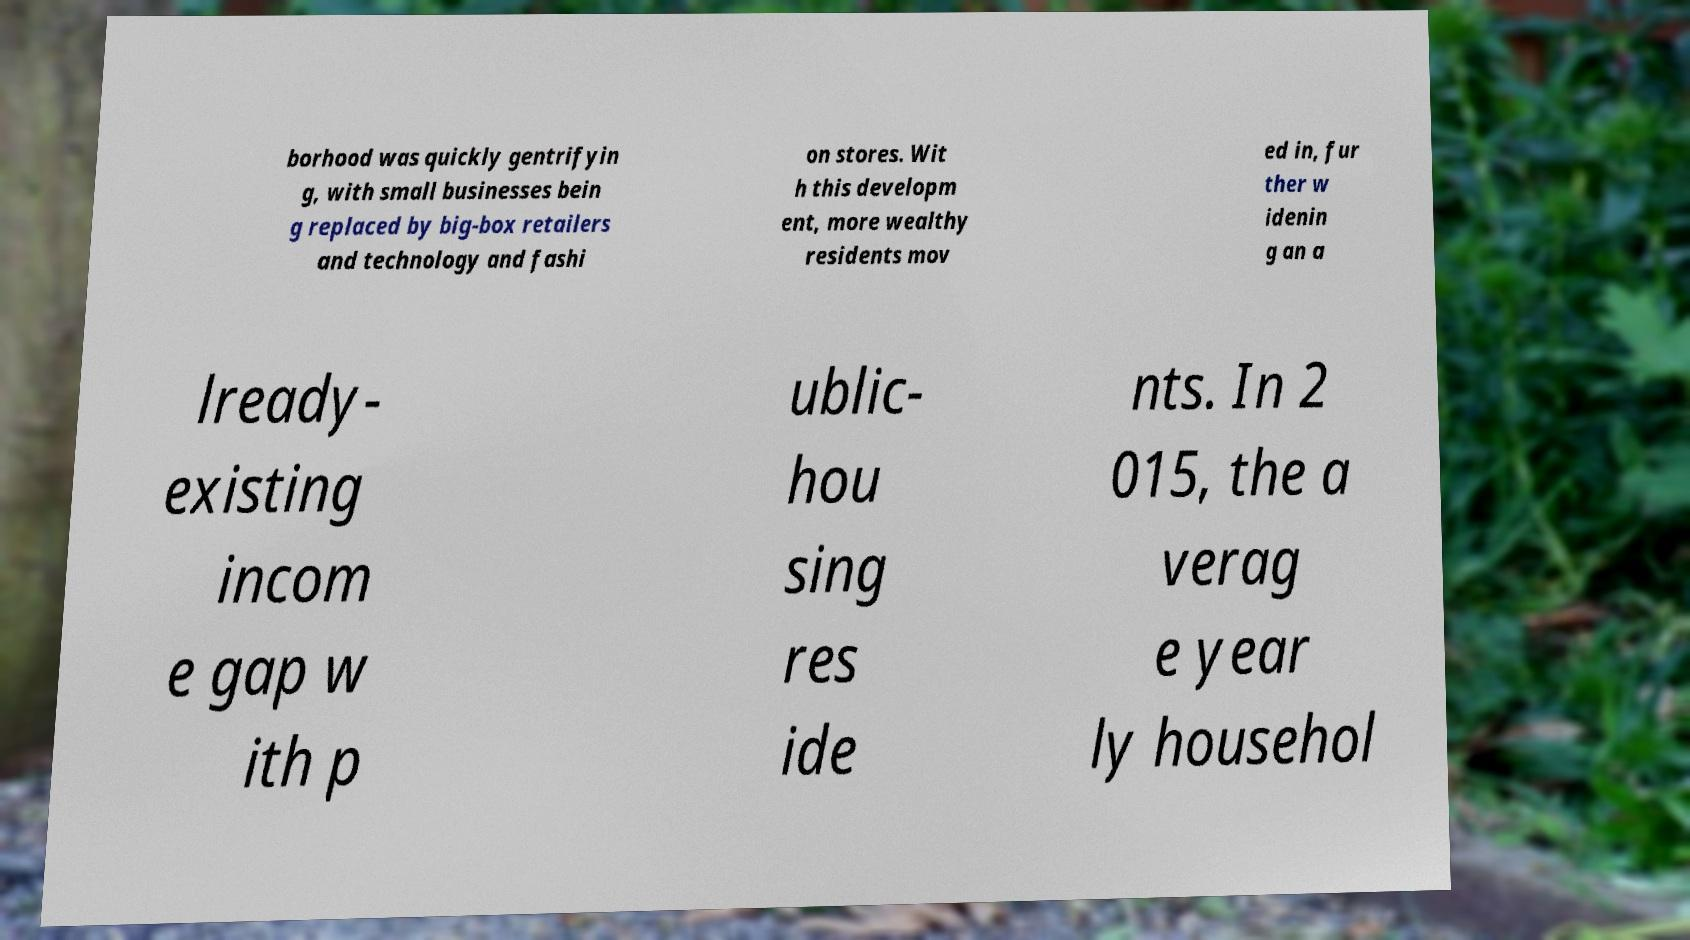Can you read and provide the text displayed in the image?This photo seems to have some interesting text. Can you extract and type it out for me? borhood was quickly gentrifyin g, with small businesses bein g replaced by big-box retailers and technology and fashi on stores. Wit h this developm ent, more wealthy residents mov ed in, fur ther w idenin g an a lready- existing incom e gap w ith p ublic- hou sing res ide nts. In 2 015, the a verag e year ly househol 